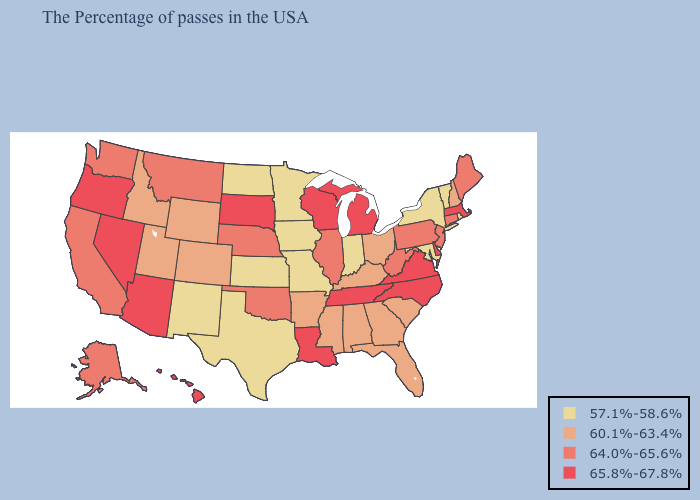What is the highest value in states that border Delaware?
Be succinct. 64.0%-65.6%. Name the states that have a value in the range 60.1%-63.4%?
Answer briefly. New Hampshire, South Carolina, Ohio, Florida, Georgia, Kentucky, Alabama, Mississippi, Arkansas, Wyoming, Colorado, Utah, Idaho. Among the states that border Indiana , which have the lowest value?
Be succinct. Ohio, Kentucky. Does Texas have the lowest value in the South?
Answer briefly. Yes. Does Pennsylvania have a lower value than Alaska?
Quick response, please. No. Among the states that border Oklahoma , which have the highest value?
Answer briefly. Arkansas, Colorado. Among the states that border West Virginia , does Virginia have the highest value?
Give a very brief answer. Yes. Name the states that have a value in the range 60.1%-63.4%?
Keep it brief. New Hampshire, South Carolina, Ohio, Florida, Georgia, Kentucky, Alabama, Mississippi, Arkansas, Wyoming, Colorado, Utah, Idaho. What is the lowest value in the MidWest?
Be succinct. 57.1%-58.6%. Name the states that have a value in the range 64.0%-65.6%?
Answer briefly. Maine, Connecticut, New Jersey, Pennsylvania, West Virginia, Illinois, Nebraska, Oklahoma, Montana, California, Washington, Alaska. Which states have the lowest value in the West?
Short answer required. New Mexico. What is the value of Alaska?
Write a very short answer. 64.0%-65.6%. Name the states that have a value in the range 57.1%-58.6%?
Short answer required. Rhode Island, Vermont, New York, Maryland, Indiana, Missouri, Minnesota, Iowa, Kansas, Texas, North Dakota, New Mexico. What is the lowest value in states that border Pennsylvania?
Be succinct. 57.1%-58.6%. Name the states that have a value in the range 57.1%-58.6%?
Keep it brief. Rhode Island, Vermont, New York, Maryland, Indiana, Missouri, Minnesota, Iowa, Kansas, Texas, North Dakota, New Mexico. 